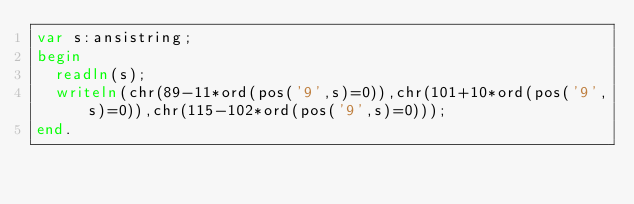<code> <loc_0><loc_0><loc_500><loc_500><_Pascal_>var s:ansistring;
begin
  readln(s);	
  writeln(chr(89-11*ord(pos('9',s)=0)),chr(101+10*ord(pos('9',s)=0)),chr(115-102*ord(pos('9',s)=0)));
end.</code> 